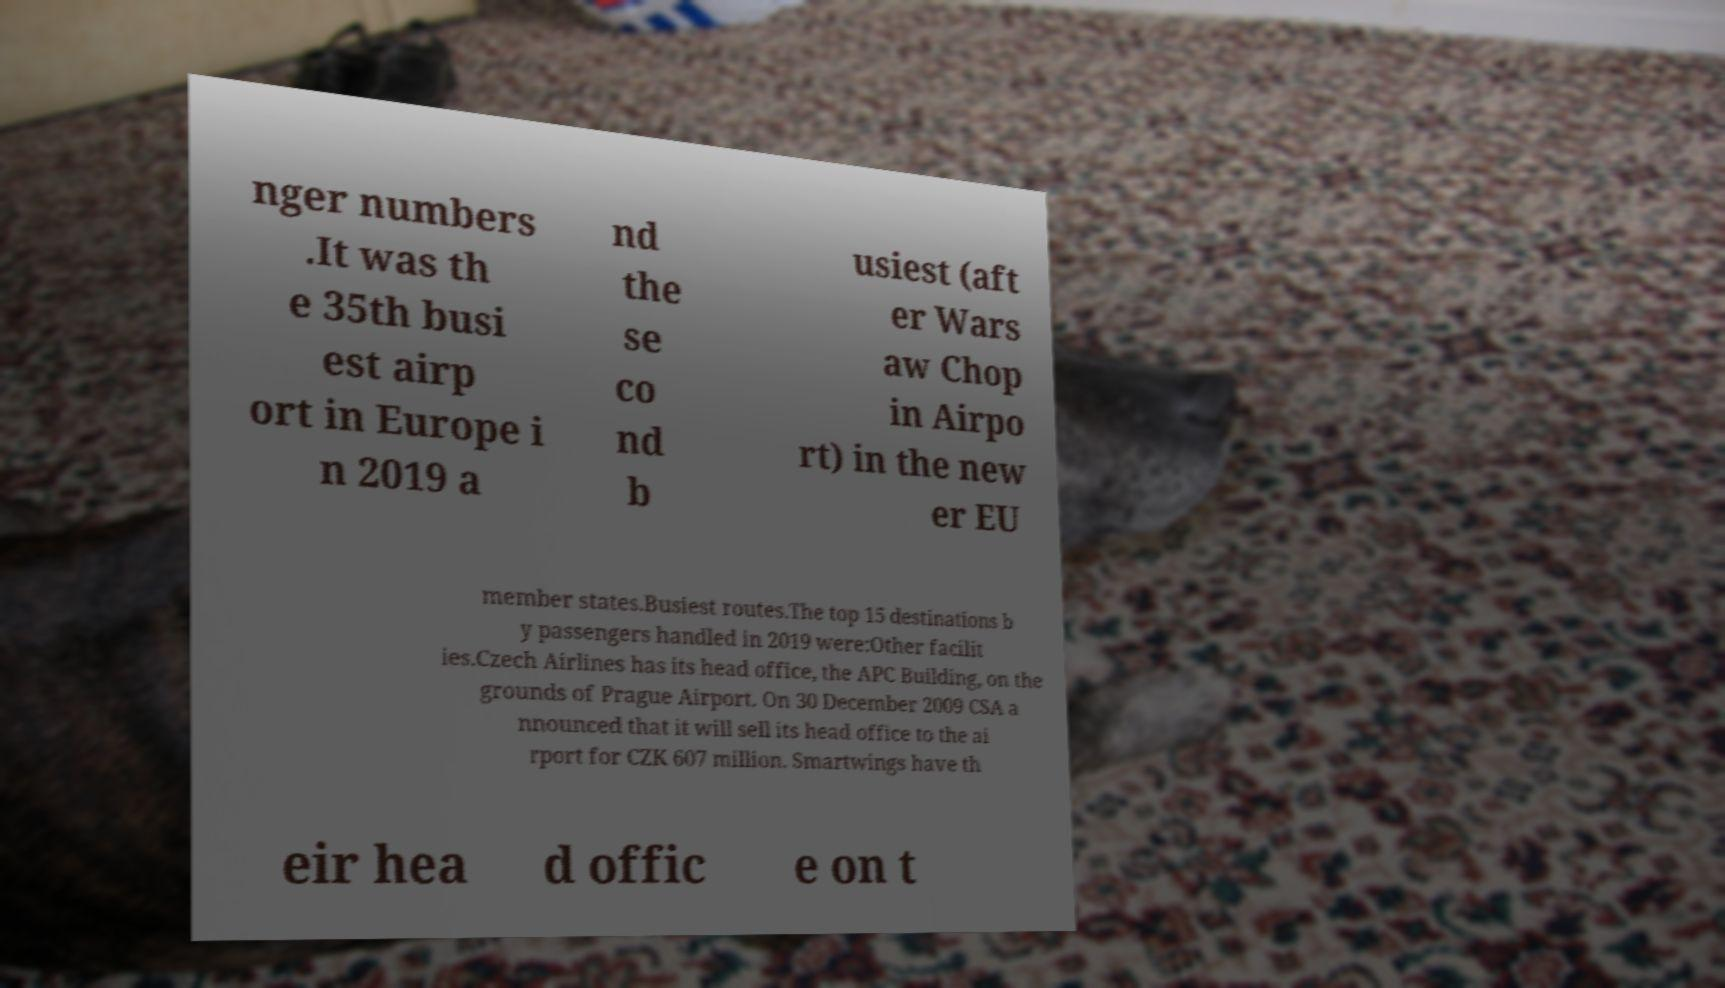Can you accurately transcribe the text from the provided image for me? nger numbers .It was th e 35th busi est airp ort in Europe i n 2019 a nd the se co nd b usiest (aft er Wars aw Chop in Airpo rt) in the new er EU member states.Busiest routes.The top 15 destinations b y passengers handled in 2019 were:Other facilit ies.Czech Airlines has its head office, the APC Building, on the grounds of Prague Airport. On 30 December 2009 CSA a nnounced that it will sell its head office to the ai rport for CZK 607 million. Smartwings have th eir hea d offic e on t 